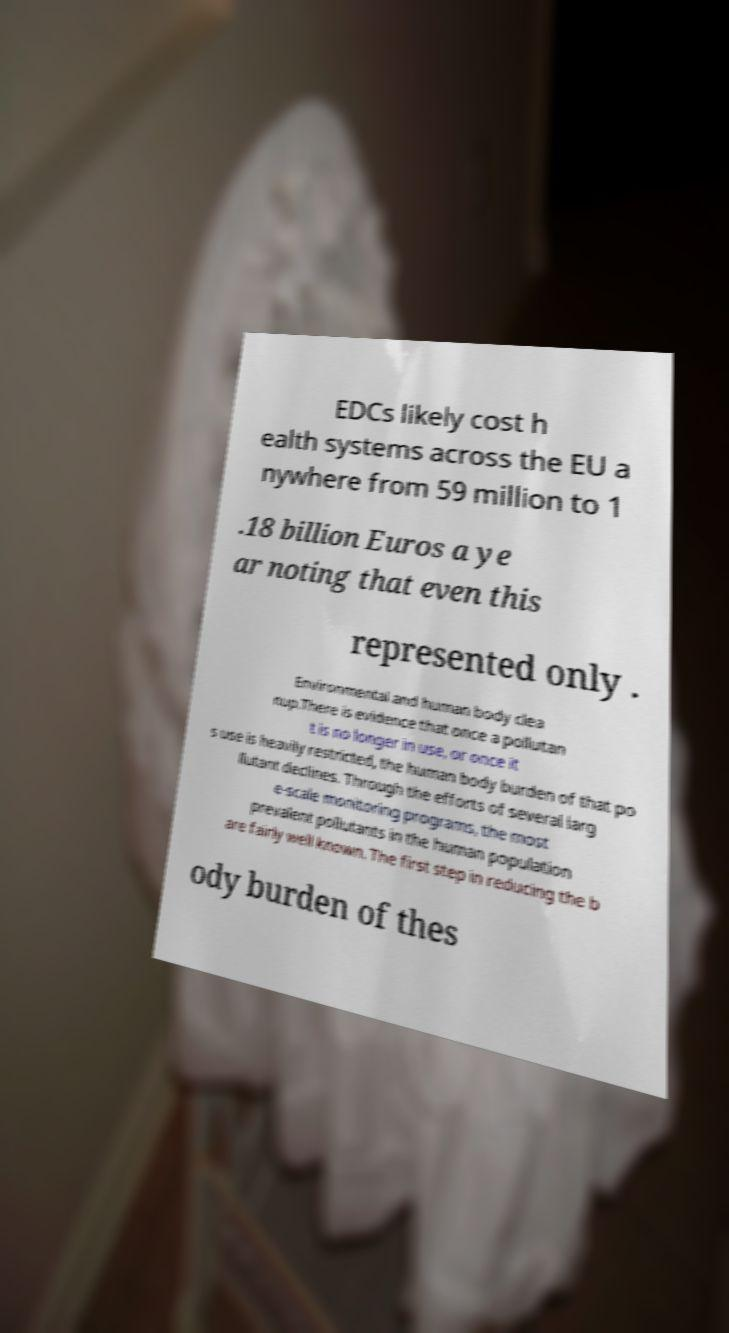Please identify and transcribe the text found in this image. EDCs likely cost h ealth systems across the EU a nywhere from 59 million to 1 .18 billion Euros a ye ar noting that even this represented only . Environmental and human body clea nup.There is evidence that once a pollutan t is no longer in use, or once it s use is heavily restricted, the human body burden of that po llutant declines. Through the efforts of several larg e-scale monitoring programs, the most prevalent pollutants in the human population are fairly well known. The first step in reducing the b ody burden of thes 